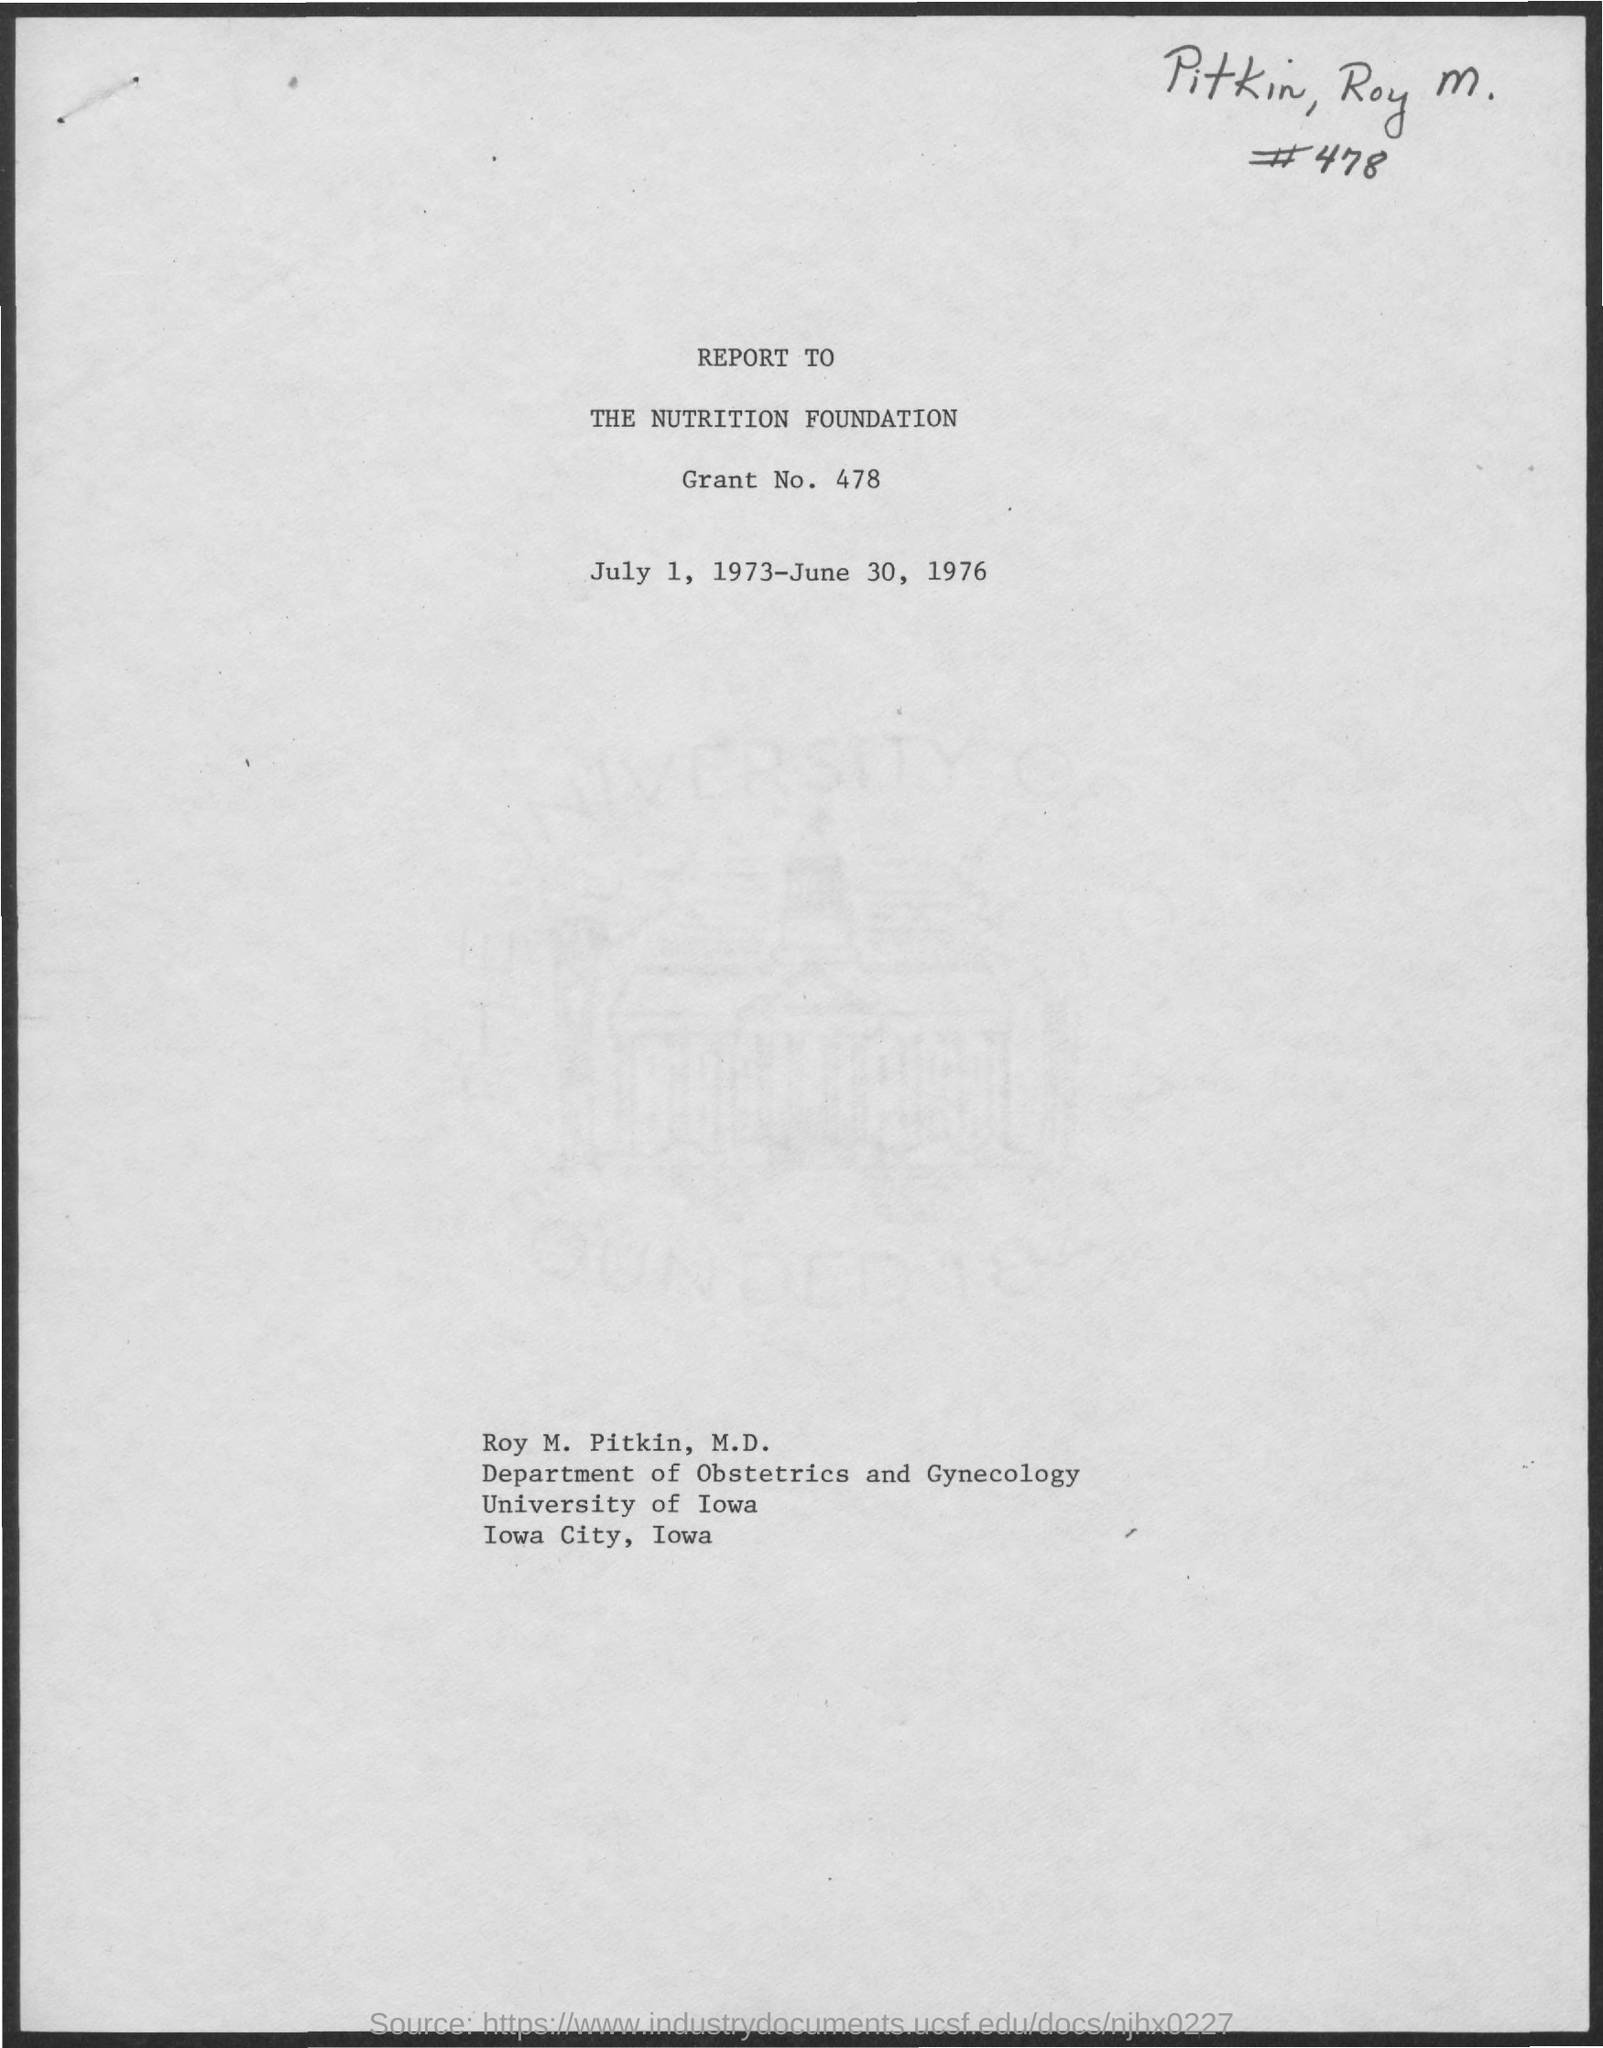Identify some key points in this picture. The University of Iowa is mentioned. The document is dated from July 1, 1973, to June 30, 1976. The name that is given is Roy M. Pitkin. The grant number is 478. 